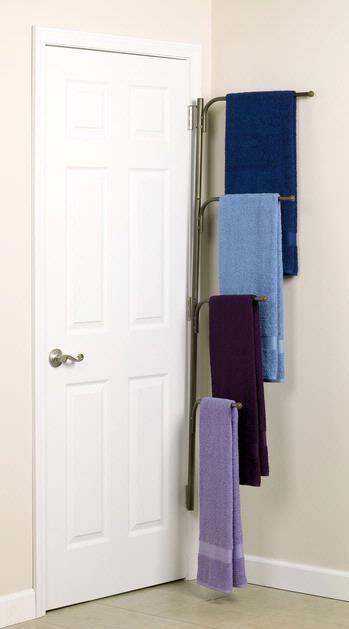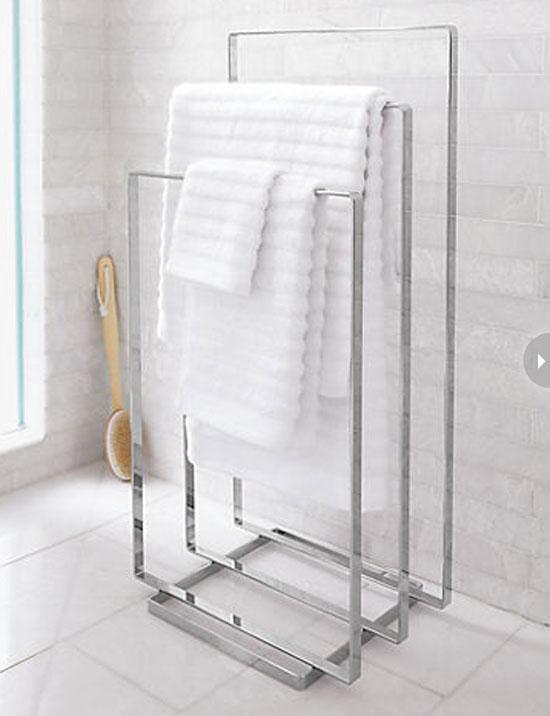The first image is the image on the left, the second image is the image on the right. Evaluate the accuracy of this statement regarding the images: "Every towel shown is hanging.". Is it true? Answer yes or no. Yes. 